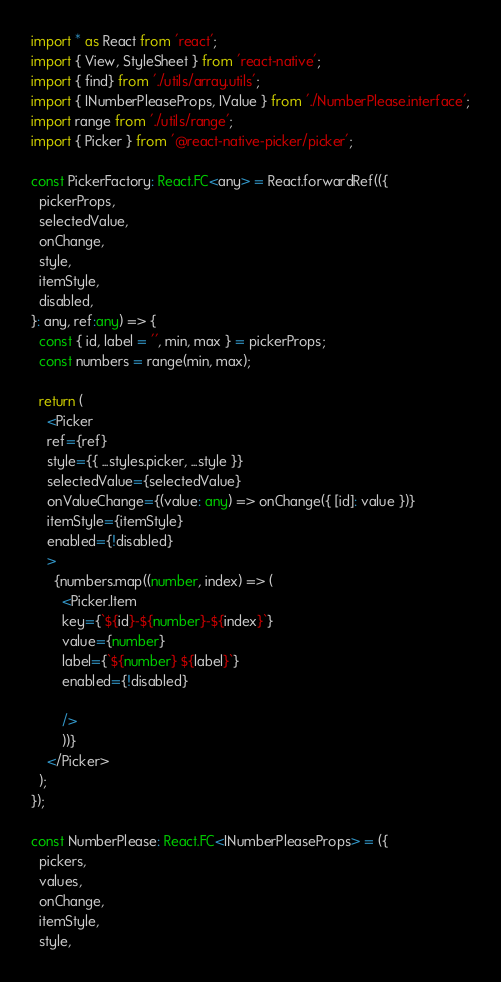<code> <loc_0><loc_0><loc_500><loc_500><_TypeScript_>import * as React from 'react';
import { View, StyleSheet } from 'react-native';
import { find} from './utils/array.utils';
import { INumberPleaseProps, IValue } from './NumberPlease.interface';
import range from './utils/range';
import { Picker } from '@react-native-picker/picker';

const PickerFactory: React.FC<any> = React.forwardRef(({
  pickerProps,
  selectedValue,
  onChange,
  style,
  itemStyle,
  disabled,
}: any, ref:any) => {
  const { id, label = '', min, max } = pickerProps;
  const numbers = range(min, max);

  return (
    <Picker
    ref={ref}
    style={{ ...styles.picker, ...style }}
    selectedValue={selectedValue}
    onValueChange={(value: any) => onChange({ [id]: value })}
    itemStyle={itemStyle}
    enabled={!disabled}
    >
      {numbers.map((number, index) => (
        <Picker.Item
        key={`${id}-${number}-${index}`}
        value={number}
        label={`${number} ${label}`}
        enabled={!disabled}

        />
        ))}
    </Picker>
  );
});

const NumberPlease: React.FC<INumberPleaseProps> = ({
  pickers,
  values,
  onChange,
  itemStyle,
  style,</code> 